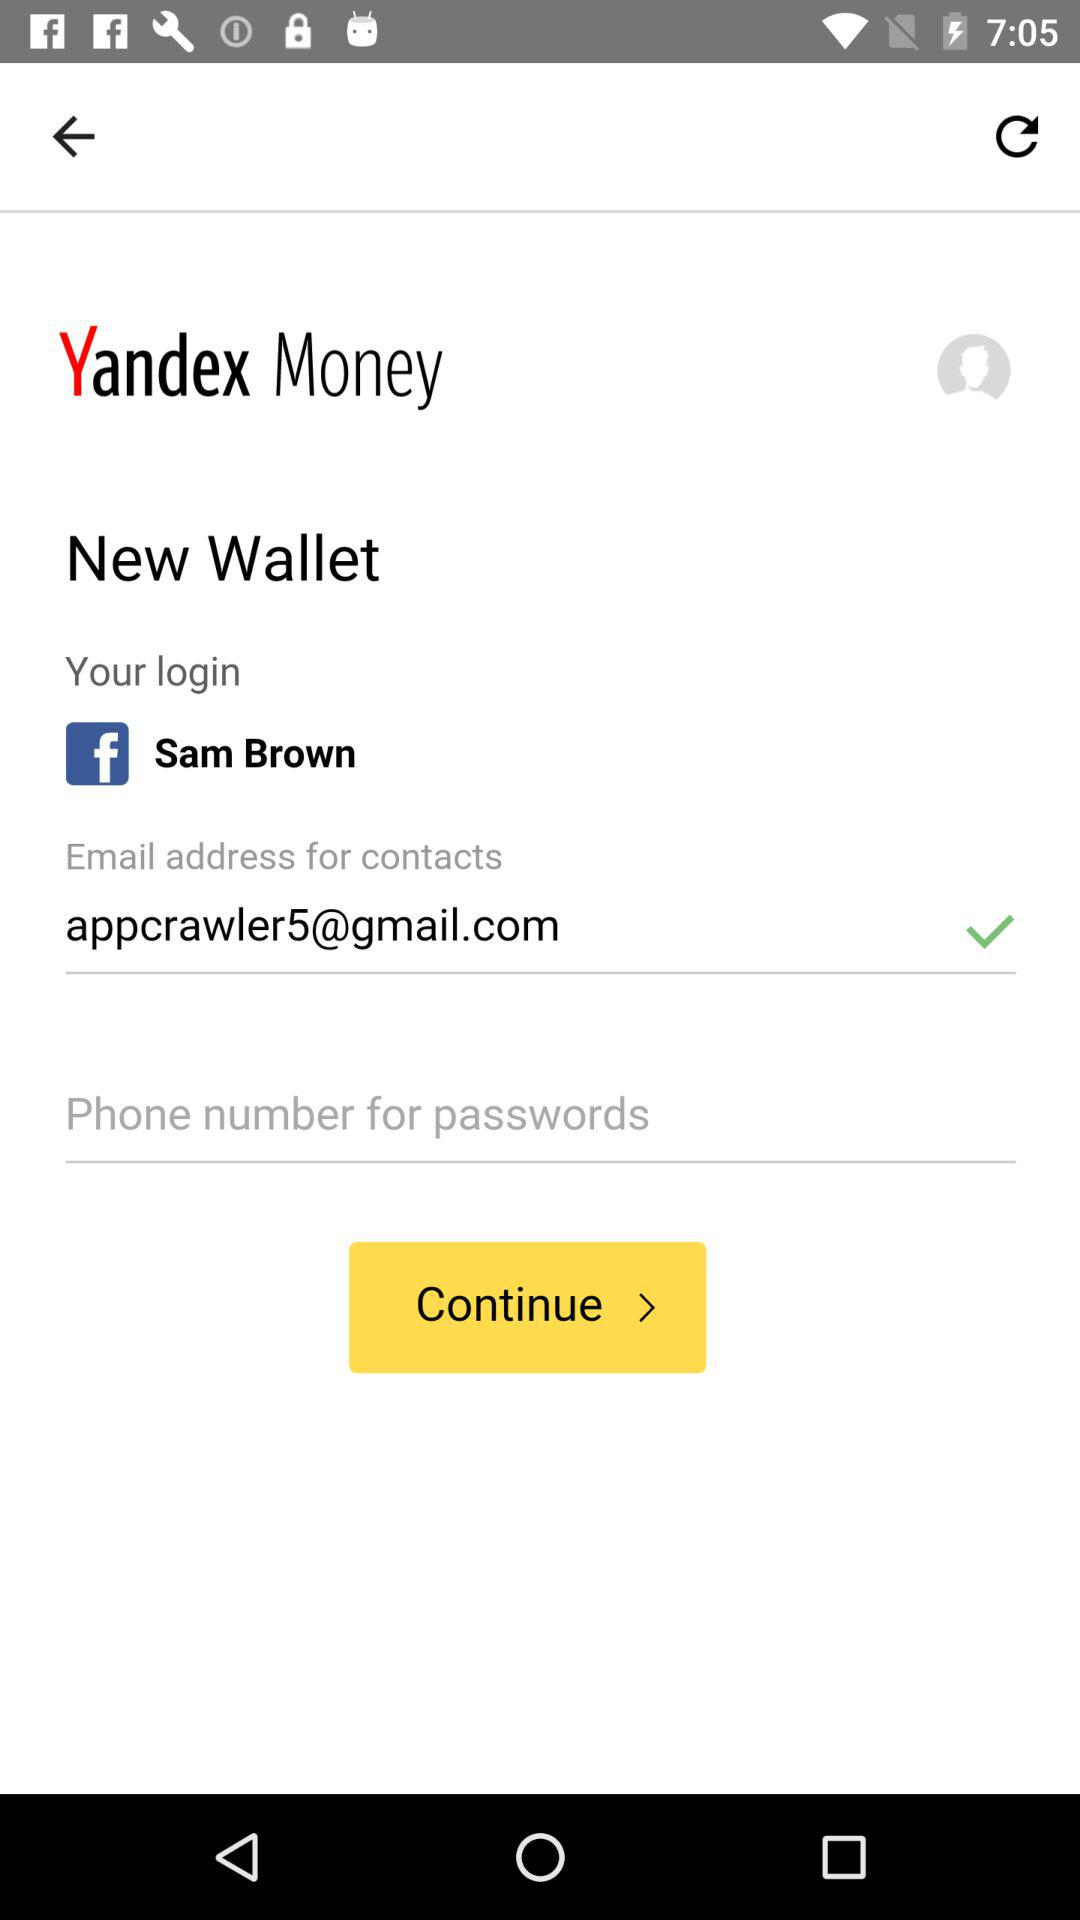What is the login profile name? The login profile name is Sam Brown. 